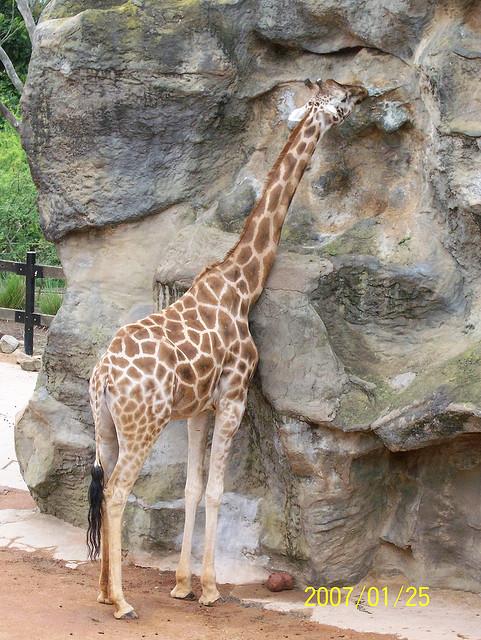Is this giraffe eating rock?
Quick response, please. No. Does this animal look sad?
Short answer required. No. Is the giraffe trying to get to the green grass?
Quick response, please. No. Does this animal appear to be in the wild?
Short answer required. No. Is the giraffe color almost similar to the rock?
Write a very short answer. No. What year was this photo taken?
Short answer required. 2007. How many animals are in this picture?
Short answer required. 1. 